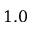Convert formula to latex. <formula><loc_0><loc_0><loc_500><loc_500>1 . 0</formula> 